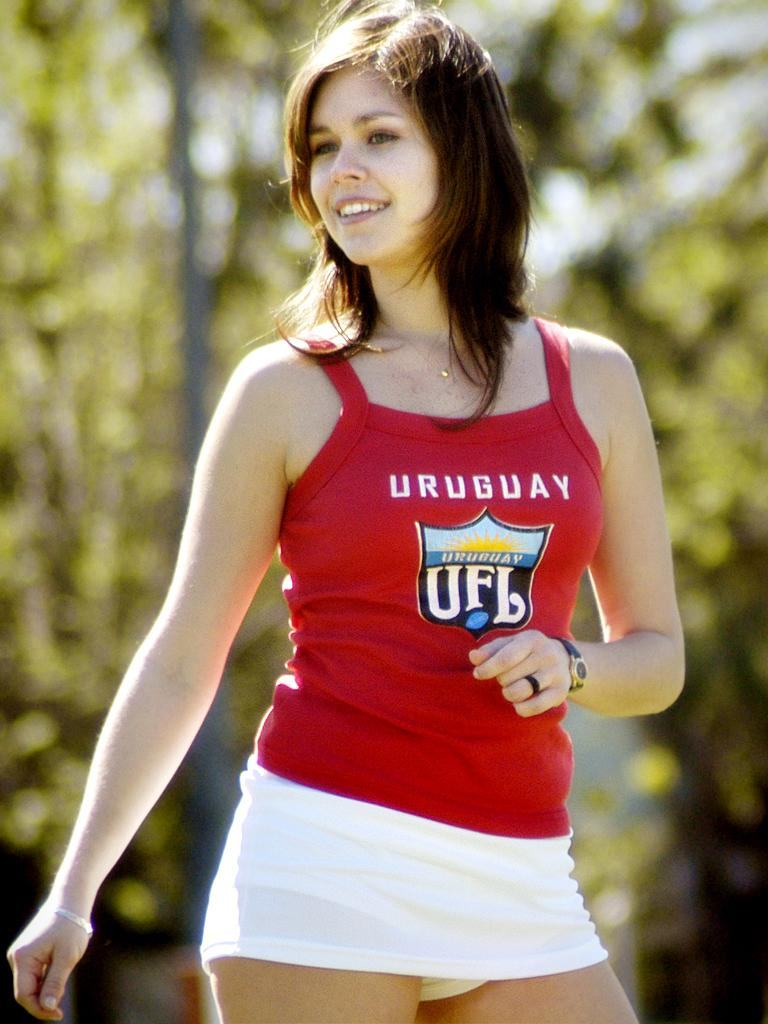Provide a one-sentence caption for the provided image. A girl wearing a white skirt and a red shirt that says Uruguay. 